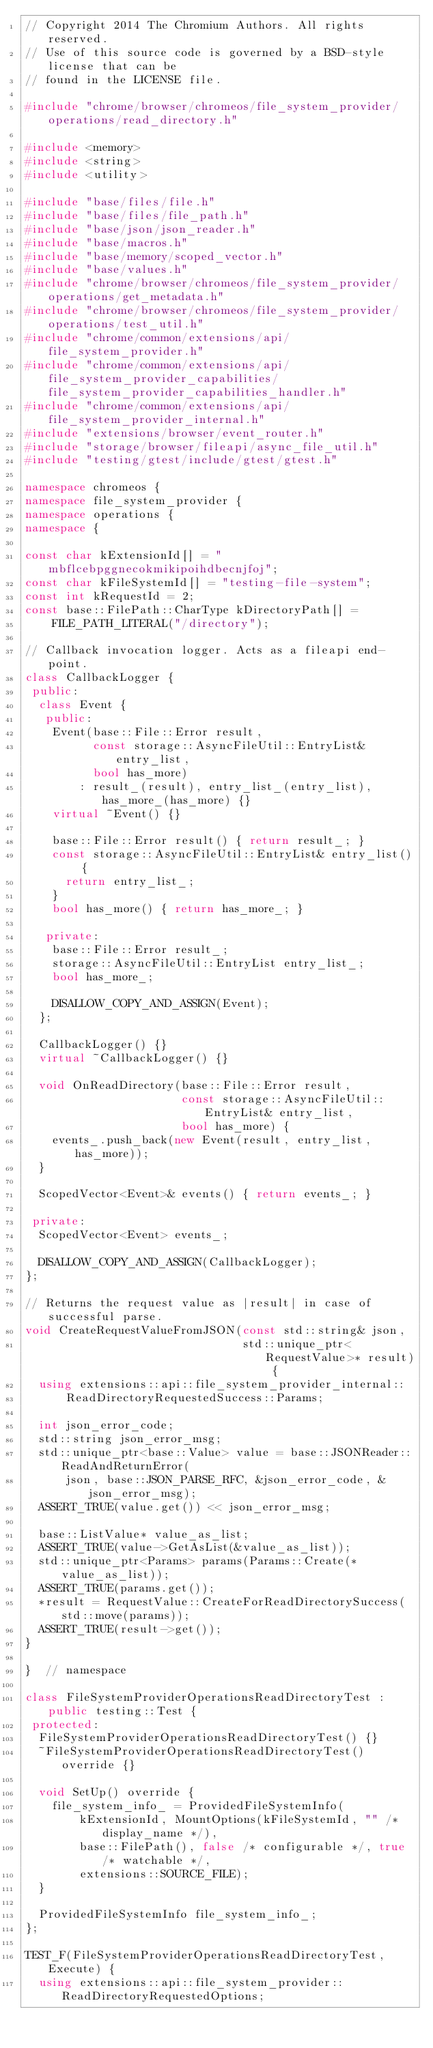Convert code to text. <code><loc_0><loc_0><loc_500><loc_500><_C++_>// Copyright 2014 The Chromium Authors. All rights reserved.
// Use of this source code is governed by a BSD-style license that can be
// found in the LICENSE file.

#include "chrome/browser/chromeos/file_system_provider/operations/read_directory.h"

#include <memory>
#include <string>
#include <utility>

#include "base/files/file.h"
#include "base/files/file_path.h"
#include "base/json/json_reader.h"
#include "base/macros.h"
#include "base/memory/scoped_vector.h"
#include "base/values.h"
#include "chrome/browser/chromeos/file_system_provider/operations/get_metadata.h"
#include "chrome/browser/chromeos/file_system_provider/operations/test_util.h"
#include "chrome/common/extensions/api/file_system_provider.h"
#include "chrome/common/extensions/api/file_system_provider_capabilities/file_system_provider_capabilities_handler.h"
#include "chrome/common/extensions/api/file_system_provider_internal.h"
#include "extensions/browser/event_router.h"
#include "storage/browser/fileapi/async_file_util.h"
#include "testing/gtest/include/gtest/gtest.h"

namespace chromeos {
namespace file_system_provider {
namespace operations {
namespace {

const char kExtensionId[] = "mbflcebpggnecokmikipoihdbecnjfoj";
const char kFileSystemId[] = "testing-file-system";
const int kRequestId = 2;
const base::FilePath::CharType kDirectoryPath[] =
    FILE_PATH_LITERAL("/directory");

// Callback invocation logger. Acts as a fileapi end-point.
class CallbackLogger {
 public:
  class Event {
   public:
    Event(base::File::Error result,
          const storage::AsyncFileUtil::EntryList& entry_list,
          bool has_more)
        : result_(result), entry_list_(entry_list), has_more_(has_more) {}
    virtual ~Event() {}

    base::File::Error result() { return result_; }
    const storage::AsyncFileUtil::EntryList& entry_list() {
      return entry_list_;
    }
    bool has_more() { return has_more_; }

   private:
    base::File::Error result_;
    storage::AsyncFileUtil::EntryList entry_list_;
    bool has_more_;

    DISALLOW_COPY_AND_ASSIGN(Event);
  };

  CallbackLogger() {}
  virtual ~CallbackLogger() {}

  void OnReadDirectory(base::File::Error result,
                       const storage::AsyncFileUtil::EntryList& entry_list,
                       bool has_more) {
    events_.push_back(new Event(result, entry_list, has_more));
  }

  ScopedVector<Event>& events() { return events_; }

 private:
  ScopedVector<Event> events_;

  DISALLOW_COPY_AND_ASSIGN(CallbackLogger);
};

// Returns the request value as |result| in case of successful parse.
void CreateRequestValueFromJSON(const std::string& json,
                                std::unique_ptr<RequestValue>* result) {
  using extensions::api::file_system_provider_internal::
      ReadDirectoryRequestedSuccess::Params;

  int json_error_code;
  std::string json_error_msg;
  std::unique_ptr<base::Value> value = base::JSONReader::ReadAndReturnError(
      json, base::JSON_PARSE_RFC, &json_error_code, &json_error_msg);
  ASSERT_TRUE(value.get()) << json_error_msg;

  base::ListValue* value_as_list;
  ASSERT_TRUE(value->GetAsList(&value_as_list));
  std::unique_ptr<Params> params(Params::Create(*value_as_list));
  ASSERT_TRUE(params.get());
  *result = RequestValue::CreateForReadDirectorySuccess(std::move(params));
  ASSERT_TRUE(result->get());
}

}  // namespace

class FileSystemProviderOperationsReadDirectoryTest : public testing::Test {
 protected:
  FileSystemProviderOperationsReadDirectoryTest() {}
  ~FileSystemProviderOperationsReadDirectoryTest() override {}

  void SetUp() override {
    file_system_info_ = ProvidedFileSystemInfo(
        kExtensionId, MountOptions(kFileSystemId, "" /* display_name */),
        base::FilePath(), false /* configurable */, true /* watchable */,
        extensions::SOURCE_FILE);
  }

  ProvidedFileSystemInfo file_system_info_;
};

TEST_F(FileSystemProviderOperationsReadDirectoryTest, Execute) {
  using extensions::api::file_system_provider::ReadDirectoryRequestedOptions;
</code> 